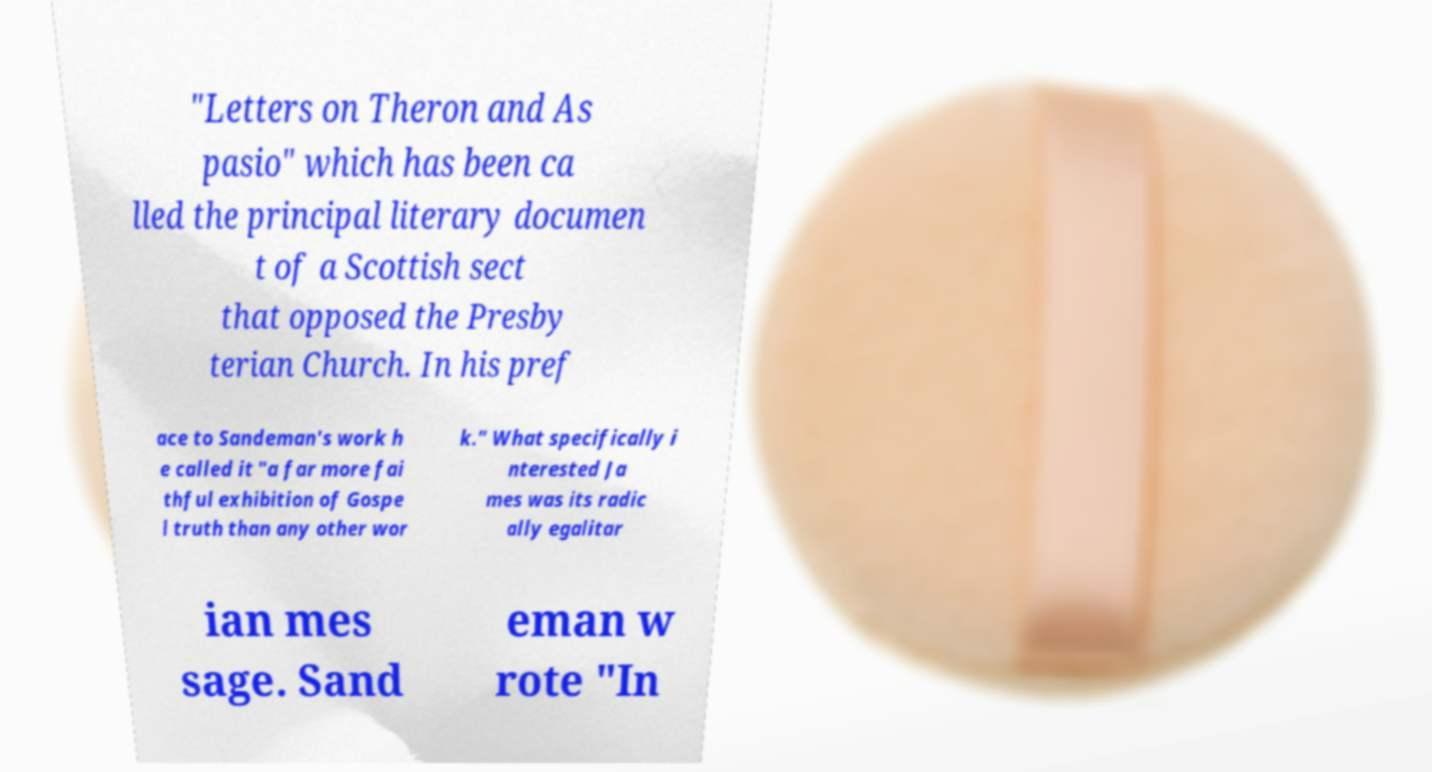Can you read and provide the text displayed in the image?This photo seems to have some interesting text. Can you extract and type it out for me? "Letters on Theron and As pasio" which has been ca lled the principal literary documen t of a Scottish sect that opposed the Presby terian Church. In his pref ace to Sandeman's work h e called it "a far more fai thful exhibition of Gospe l truth than any other wor k." What specifically i nterested Ja mes was its radic ally egalitar ian mes sage. Sand eman w rote "In 